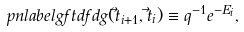<formula> <loc_0><loc_0><loc_500><loc_500>\ p n l a b e l { g f t d f d } g ( \vec { t } _ { i + 1 } , \vec { t } _ { i } ) \equiv q ^ { - 1 } e ^ { - E _ { i } } ,</formula> 